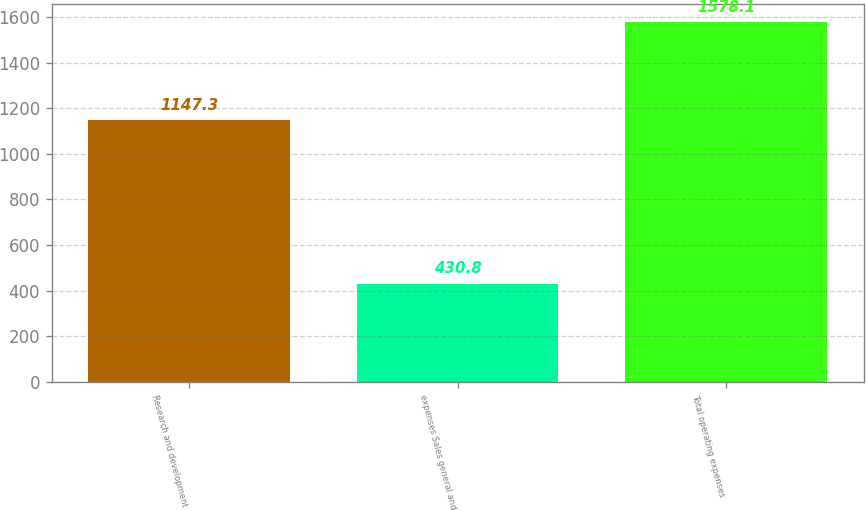<chart> <loc_0><loc_0><loc_500><loc_500><bar_chart><fcel>Research and development<fcel>expenses Sales general and<fcel>Total operating expenses<nl><fcel>1147.3<fcel>430.8<fcel>1578.1<nl></chart> 